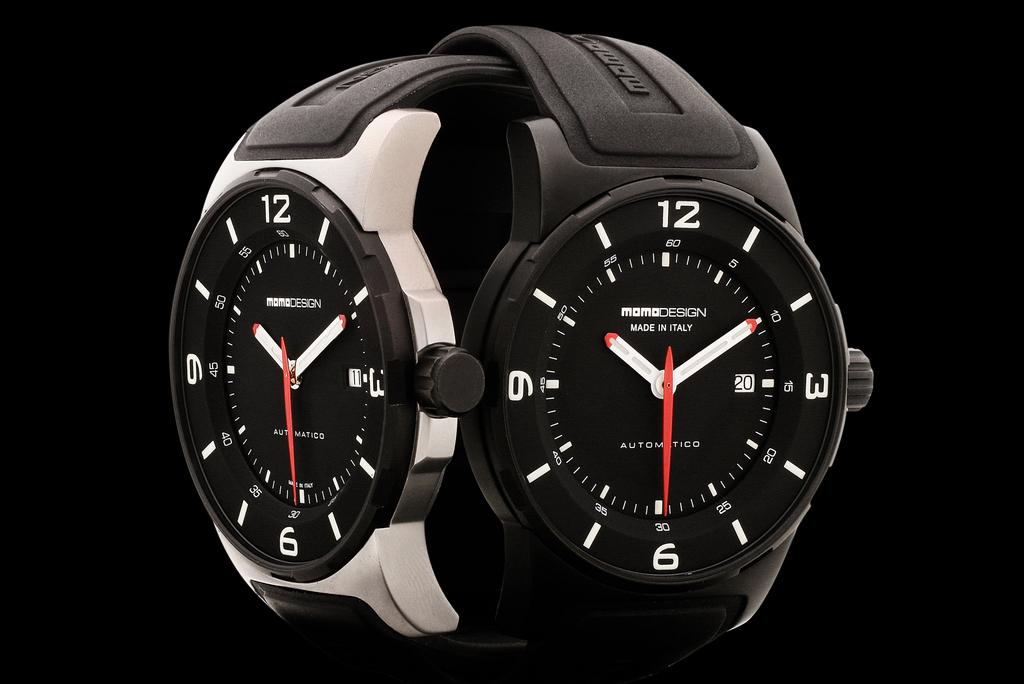Provide a one-sentence caption for the provided image. Two watches both display a time of 10:10:30. 